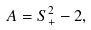Convert formula to latex. <formula><loc_0><loc_0><loc_500><loc_500>A = S _ { + } ^ { 2 } - 2 ,</formula> 